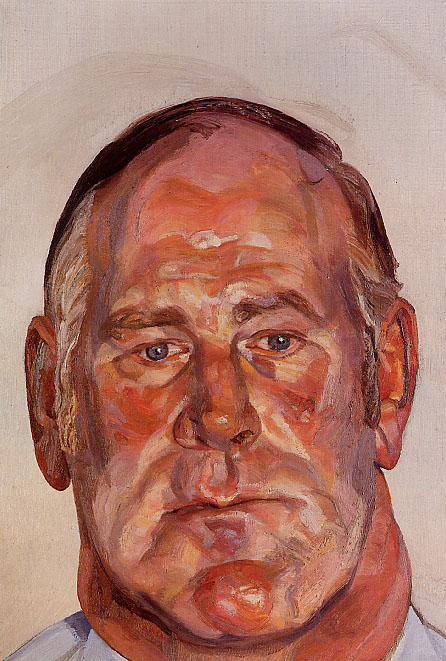What emotions does this painting evoke for you? This painting evokes a mix of deep introspection and serenity. The man's closed eyes and the warm, vibrant colors create a sense of peace and reflection. It feels as though he is in a moment of personal thought, possibly reminiscing about past experiences or contemplating the future. There's a touch of melancholy in his expression, but also a profound sense of acceptance and inner calm. The thick, dynamic brushstrokes add a sense of life and movement to the piece, making it feel emotionally charged yet deeply meditative. 